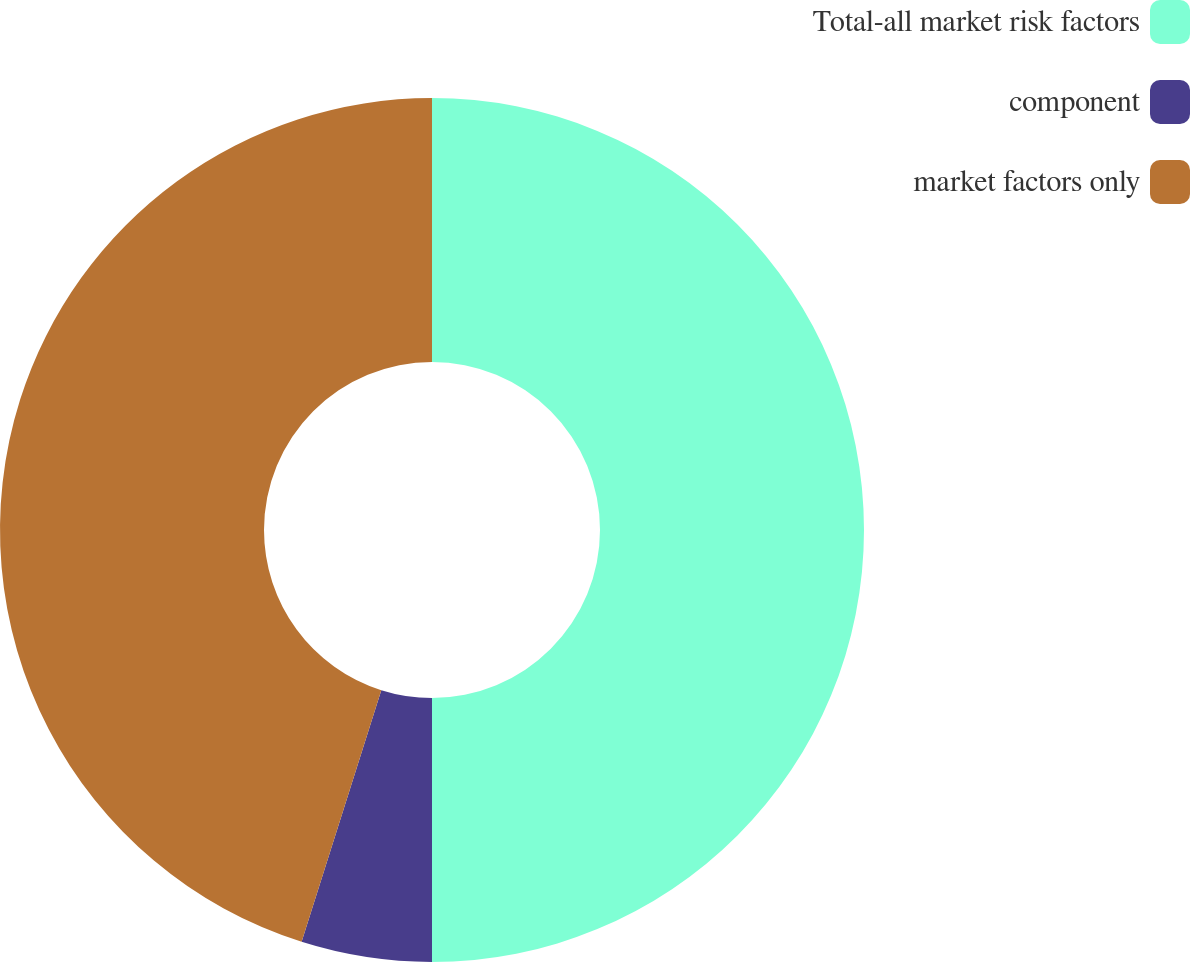Convert chart to OTSL. <chart><loc_0><loc_0><loc_500><loc_500><pie_chart><fcel>Total-all market risk factors<fcel>component<fcel>market factors only<nl><fcel>50.0%<fcel>4.88%<fcel>45.12%<nl></chart> 